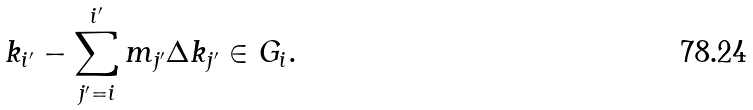<formula> <loc_0><loc_0><loc_500><loc_500>k _ { i ^ { \prime } } - \sum _ { j ^ { \prime } = i } ^ { i ^ { \prime } } m _ { j ^ { \prime } } \Delta k _ { j ^ { \prime } } \in G _ { i } .</formula> 